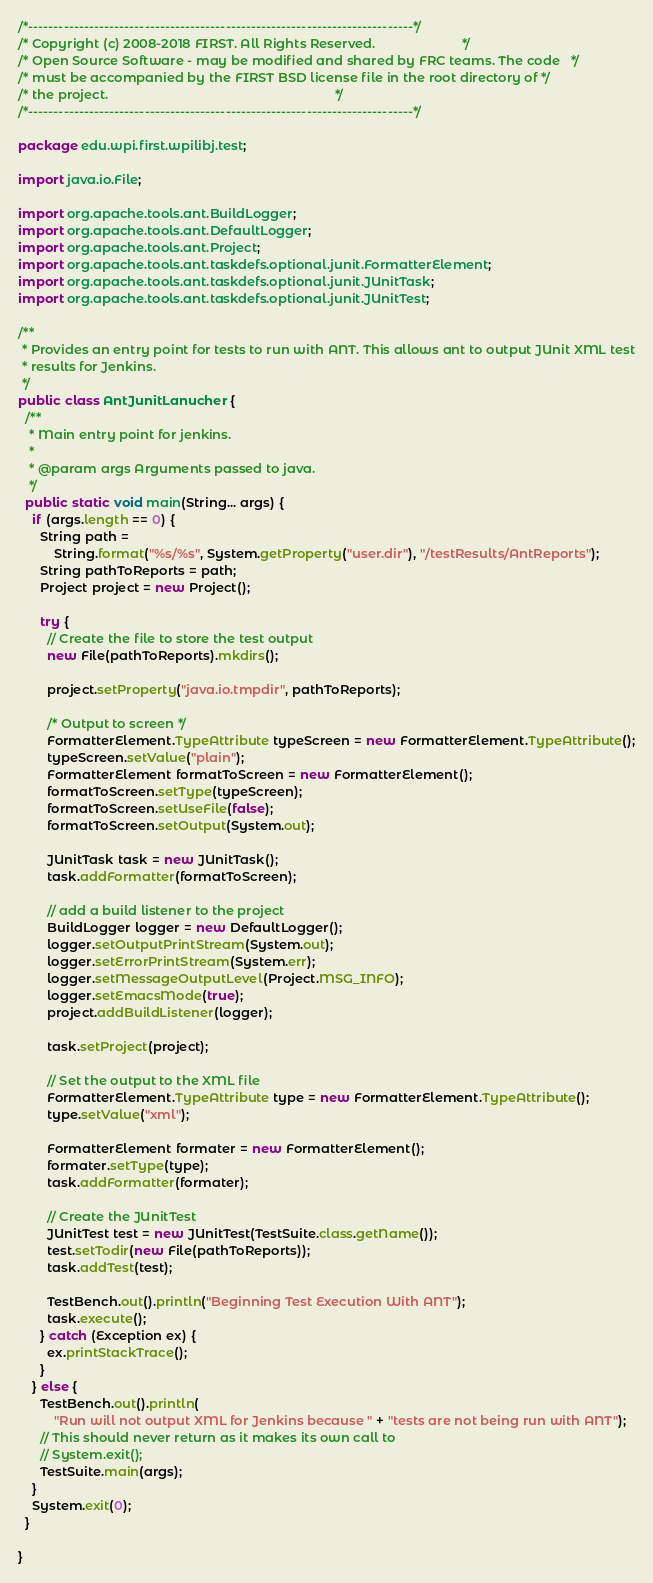Convert code to text. <code><loc_0><loc_0><loc_500><loc_500><_Java_>/*----------------------------------------------------------------------------*/
/* Copyright (c) 2008-2018 FIRST. All Rights Reserved.                        */
/* Open Source Software - may be modified and shared by FRC teams. The code   */
/* must be accompanied by the FIRST BSD license file in the root directory of */
/* the project.                                                               */
/*----------------------------------------------------------------------------*/

package edu.wpi.first.wpilibj.test;

import java.io.File;

import org.apache.tools.ant.BuildLogger;
import org.apache.tools.ant.DefaultLogger;
import org.apache.tools.ant.Project;
import org.apache.tools.ant.taskdefs.optional.junit.FormatterElement;
import org.apache.tools.ant.taskdefs.optional.junit.JUnitTask;
import org.apache.tools.ant.taskdefs.optional.junit.JUnitTest;

/**
 * Provides an entry point for tests to run with ANT. This allows ant to output JUnit XML test
 * results for Jenkins.
 */
public class AntJunitLanucher {
  /**
   * Main entry point for jenkins.
   *
   * @param args Arguments passed to java.
   */
  public static void main(String... args) {
    if (args.length == 0) {
      String path =
          String.format("%s/%s", System.getProperty("user.dir"), "/testResults/AntReports");
      String pathToReports = path;
      Project project = new Project();

      try {
        // Create the file to store the test output
        new File(pathToReports).mkdirs();

        project.setProperty("java.io.tmpdir", pathToReports);

        /* Output to screen */
        FormatterElement.TypeAttribute typeScreen = new FormatterElement.TypeAttribute();
        typeScreen.setValue("plain");
        FormatterElement formatToScreen = new FormatterElement();
        formatToScreen.setType(typeScreen);
        formatToScreen.setUseFile(false);
        formatToScreen.setOutput(System.out);

        JUnitTask task = new JUnitTask();
        task.addFormatter(formatToScreen);

        // add a build listener to the project
        BuildLogger logger = new DefaultLogger();
        logger.setOutputPrintStream(System.out);
        logger.setErrorPrintStream(System.err);
        logger.setMessageOutputLevel(Project.MSG_INFO);
        logger.setEmacsMode(true);
        project.addBuildListener(logger);

        task.setProject(project);

        // Set the output to the XML file
        FormatterElement.TypeAttribute type = new FormatterElement.TypeAttribute();
        type.setValue("xml");

        FormatterElement formater = new FormatterElement();
        formater.setType(type);
        task.addFormatter(formater);

        // Create the JUnitTest
        JUnitTest test = new JUnitTest(TestSuite.class.getName());
        test.setTodir(new File(pathToReports));
        task.addTest(test);

        TestBench.out().println("Beginning Test Execution With ANT");
        task.execute();
      } catch (Exception ex) {
        ex.printStackTrace();
      }
    } else {
      TestBench.out().println(
          "Run will not output XML for Jenkins because " + "tests are not being run with ANT");
      // This should never return as it makes its own call to
      // System.exit();
      TestSuite.main(args);
    }
    System.exit(0);
  }

}
</code> 